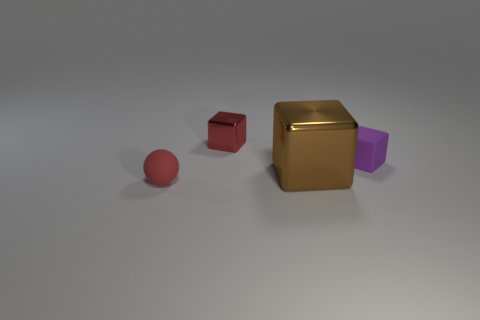Subtract all shiny blocks. How many blocks are left? 1 Add 2 metal objects. How many objects exist? 6 Subtract all balls. How many objects are left? 3 Subtract all red rubber balls. Subtract all small matte cubes. How many objects are left? 2 Add 3 red blocks. How many red blocks are left? 4 Add 3 big gray rubber spheres. How many big gray rubber spheres exist? 3 Subtract 0 blue blocks. How many objects are left? 4 Subtract all red cubes. Subtract all blue spheres. How many cubes are left? 2 